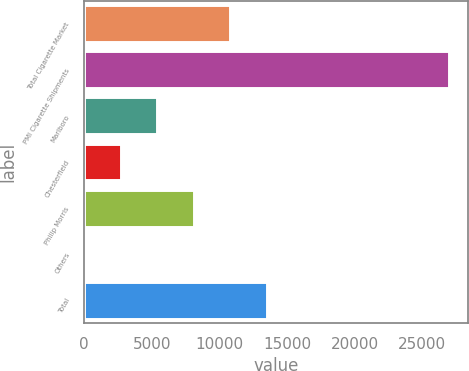Convert chart. <chart><loc_0><loc_0><loc_500><loc_500><bar_chart><fcel>Total Cigarette Market<fcel>PMI Cigarette Shipments<fcel>Marlboro<fcel>Chesterfield<fcel>Philip Morris<fcel>Others<fcel>Total<nl><fcel>10804.3<fcel>27002<fcel>5405.04<fcel>2705.42<fcel>8104.66<fcel>5.8<fcel>13503.9<nl></chart> 